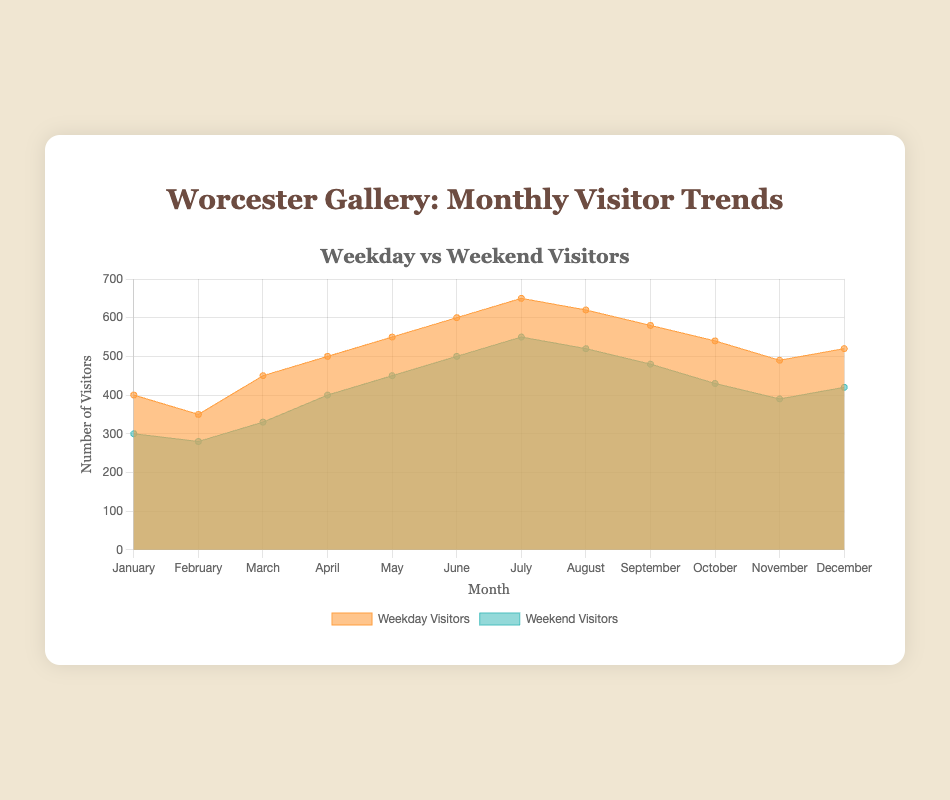How many total visitors were there in March? To find the total number of visitors in March, sum the weekday and weekend visitors for that month. For March: 450 (weekday) + 330 (weekend) = 780 visitors.
Answer: 780 When were the most weekday visitors recorded? Look at the graph and compare the weekday visitors across all months. The highest number of weekday visitors was in July with 650 visitors.
Answer: July By how much did the total number of visitors change from January to June? Calculate the total number of visitors for January and June by summing their weekday and weekend visitors. For January: 400 + 300 = 700. For June: 600 + 500 = 1100. The change from January to June is 1100 - 700 = 400 visitors.
Answer: 400 What is the general trend for weekend visitors from January to December? Observe the weekend visitors line on the graph. The weekend visitors generally increase from January (300) to July (550), then decrease towards December (420).
Answer: Increase, then decrease Which month had the smallest difference between weekday and weekend visitors? Calculate the difference between weekday and weekend visitors for each month and identify the smallest. February has the smallest difference: 350 (weekday) - 280 (weekend) = 70.
Answer: February When did weekday visitors first exceed 600? Find the first month where the weekday visitor count is greater than 600. This occurs in June with 600 visitors.
Answer: June By how much did weekend visitors increase from April to July? Calculate the difference in weekend visitors from April to July. For April: 400 and for July: 550. The increase is 550 - 400 = 150 visitors.
Answer: 150 Which month observed a decline in both weekday and weekend visitors compared to the previous month? Identify the month where both weekday and weekend visitors are lower than the previous month. October (Weekday: 540, Weekend: 430) had lower visitors compared to September (Weekday: 580, Weekend: 480).
Answer: October What is the average number of visitors per month across the year? Find the total number of visitors across the year and then divide by 12 (months). Sum of monthly visitors: (700 + 630 + 780 + 900 + 1000 + 1100 + 1200 + 1140 + 1060 + 970 + 880 + 940) = 11300. Average: 11300 / 12 ≈ 942.
Answer: 942 